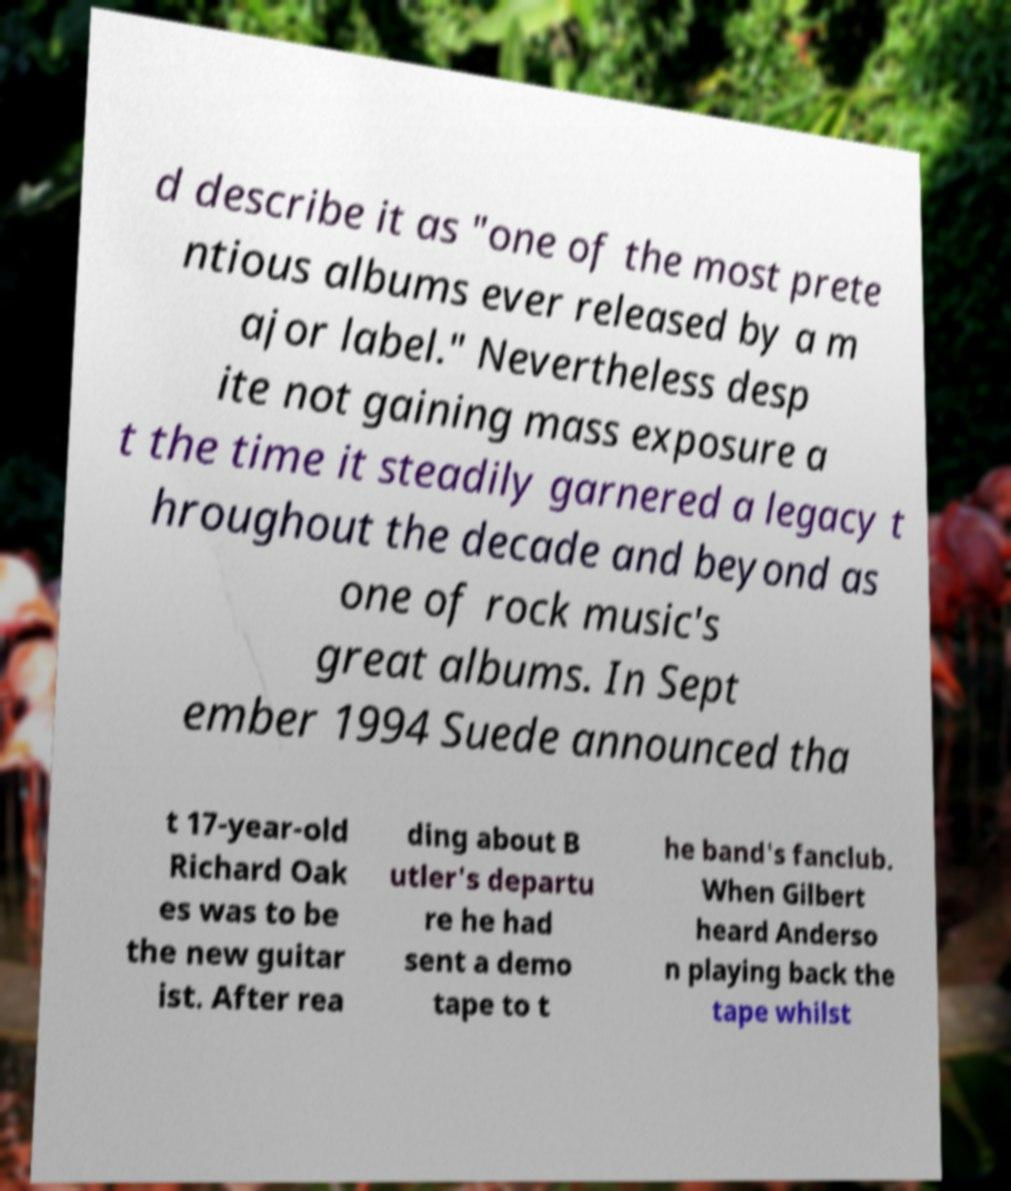Could you assist in decoding the text presented in this image and type it out clearly? d describe it as "one of the most prete ntious albums ever released by a m ajor label." Nevertheless desp ite not gaining mass exposure a t the time it steadily garnered a legacy t hroughout the decade and beyond as one of rock music's great albums. In Sept ember 1994 Suede announced tha t 17-year-old Richard Oak es was to be the new guitar ist. After rea ding about B utler's departu re he had sent a demo tape to t he band's fanclub. When Gilbert heard Anderso n playing back the tape whilst 